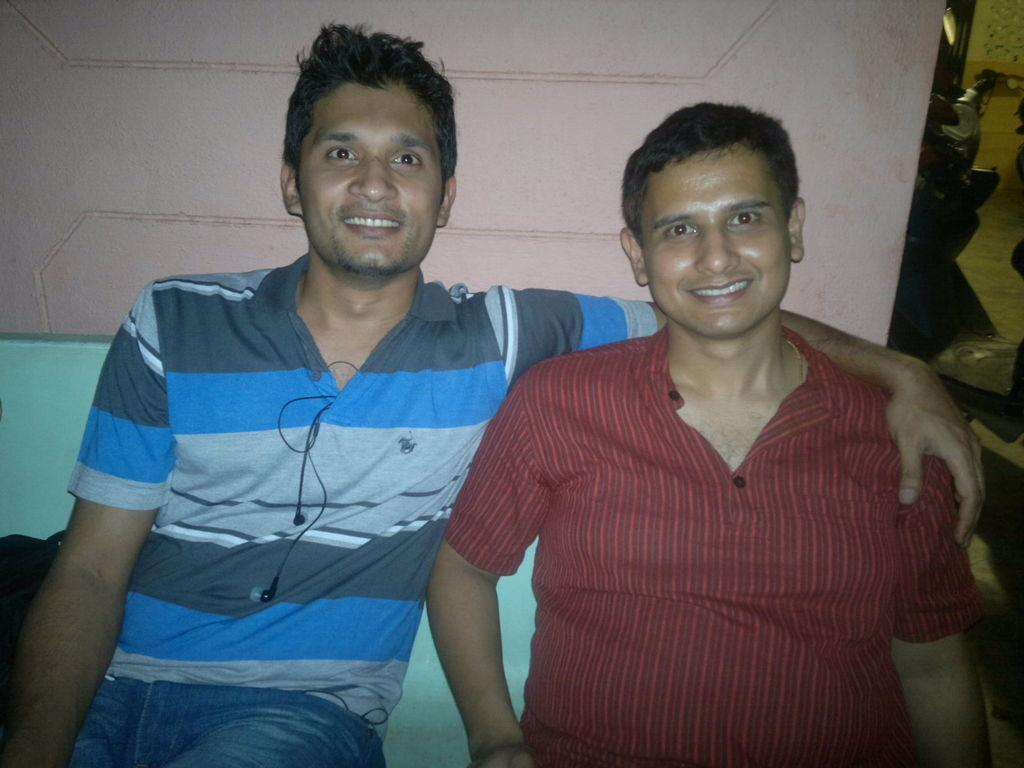How many people are sitting in the image? There are two men sitting in the image. What expression do the men have in the image? The men are smiling in the image. What is behind the men in the image? There is a wall behind the men in the image. What can be seen to the right of the men in the image? There are a few objects to the right of the men in the image. What finger is the man on the left using to talk in the image? There is no indication in the image that the men are talking or using their fingers to communicate. 